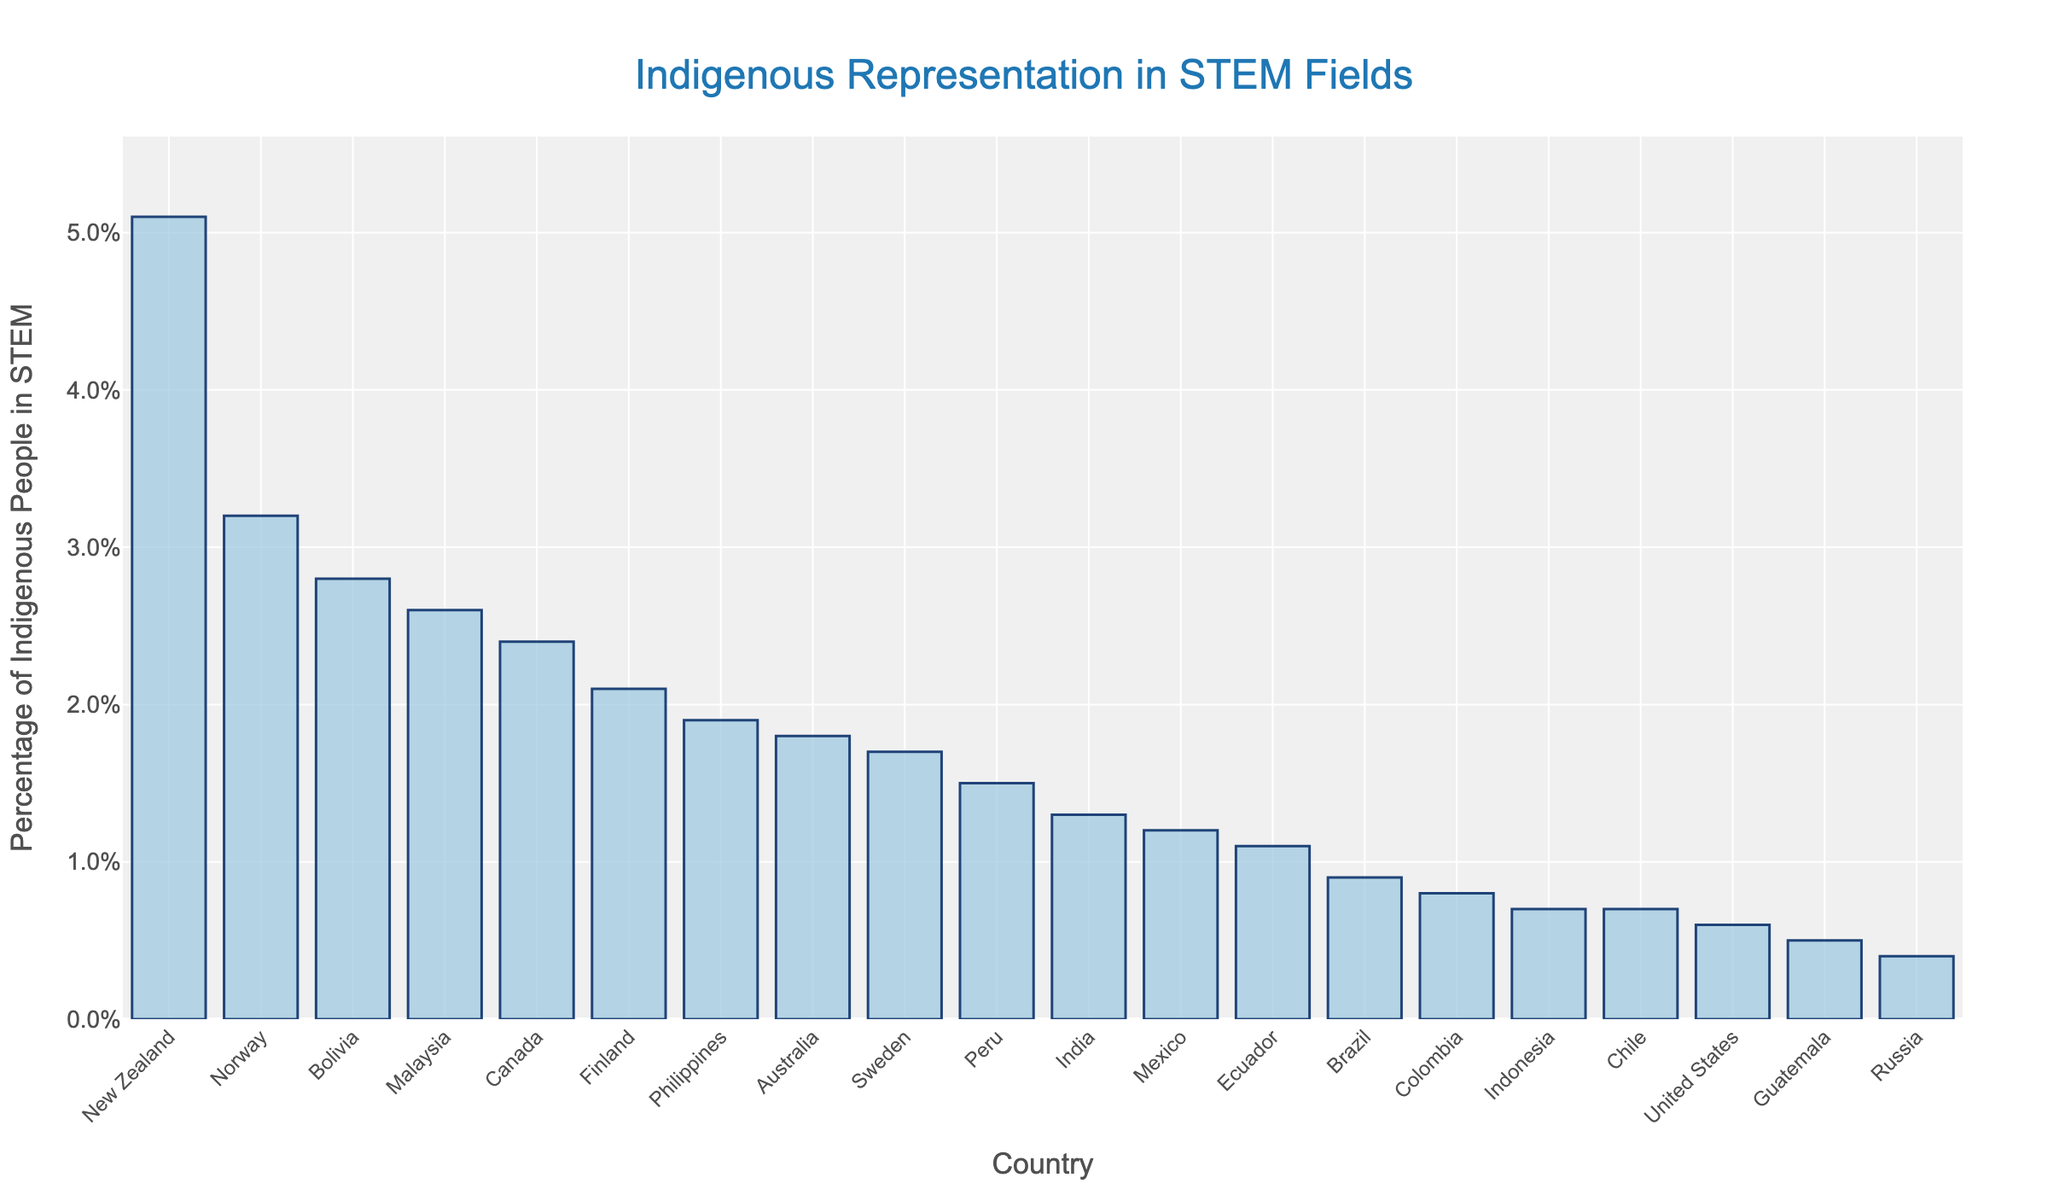Which country has the highest percentage of Indigenous people in STEM fields? Looking at the bar chart, the tallest bar represents New Zealand, indicating it has the highest percentage of Indigenous people in STEM fields among the listed countries.
Answer: New Zealand Which country has the lowest percentage of Indigenous people in STEM fields? In the bar chart, the shortest bar represents Russia, showing it has the lowest percentage of Indigenous people in STEM fields among the listed countries.
Answer: Russia What is the difference in the percentage of Indigenous people in STEM fields between Norway and Sweden? From the chart, Norway's bar is at 3.2%, and Sweden's bar is at 1.7%. Subtracting these gives 3.2% - 1.7%.
Answer: 1.5% Which countries have more than 2% of Indigenous people in STEM fields? By observing the bars higher than 2%, we identify Australia (2.4%), Malaysia (2.6%), Bolivia (2.8%), Norway (3.2%), and New Zealand (5.1%).
Answer: Canada, Malaysia, Bolivia, Norway, New Zealand What is the average percentage of Indigenous people in STEM fields across the countries shown? Sum all the percentages and divide by the number of countries. Adding the values (1.8 + 2.4 + 5.1 + 0.6 + 1.2 + 0.9 + 0.7 + 1.5 + 0.8 + 1.1 + 0.5 + 2.8 + 3.2 + 1.7 + 2.1 + 0.4 + 1.3 + 2.6 + 1.9 + 0.7) equals 37.4%. Dividing by 20 countries.
Answer: 1.87% How many countries have a percentage of Indigenous people in STEM fields between 1% and 2%? Count the number of bars that fall between 1% and 2% in height. These countries are Australia, Ecuador, India, Philippines.
Answer: 4 Which countries have a percentage lower than the overall average? The average percentage calculated is 1.87%. By comparing each country's bar height to this average, countries below are United States, Mexico, Brazil, Chile, Peru, Colombia, Ecuador, Guatemala, Bolivia, Russia, and Indonesia.
Answer: United States, Mexico, Brazil, Chile, Peru, Colombia, Ecuador, Guatemala, Russia, and Indonesia 